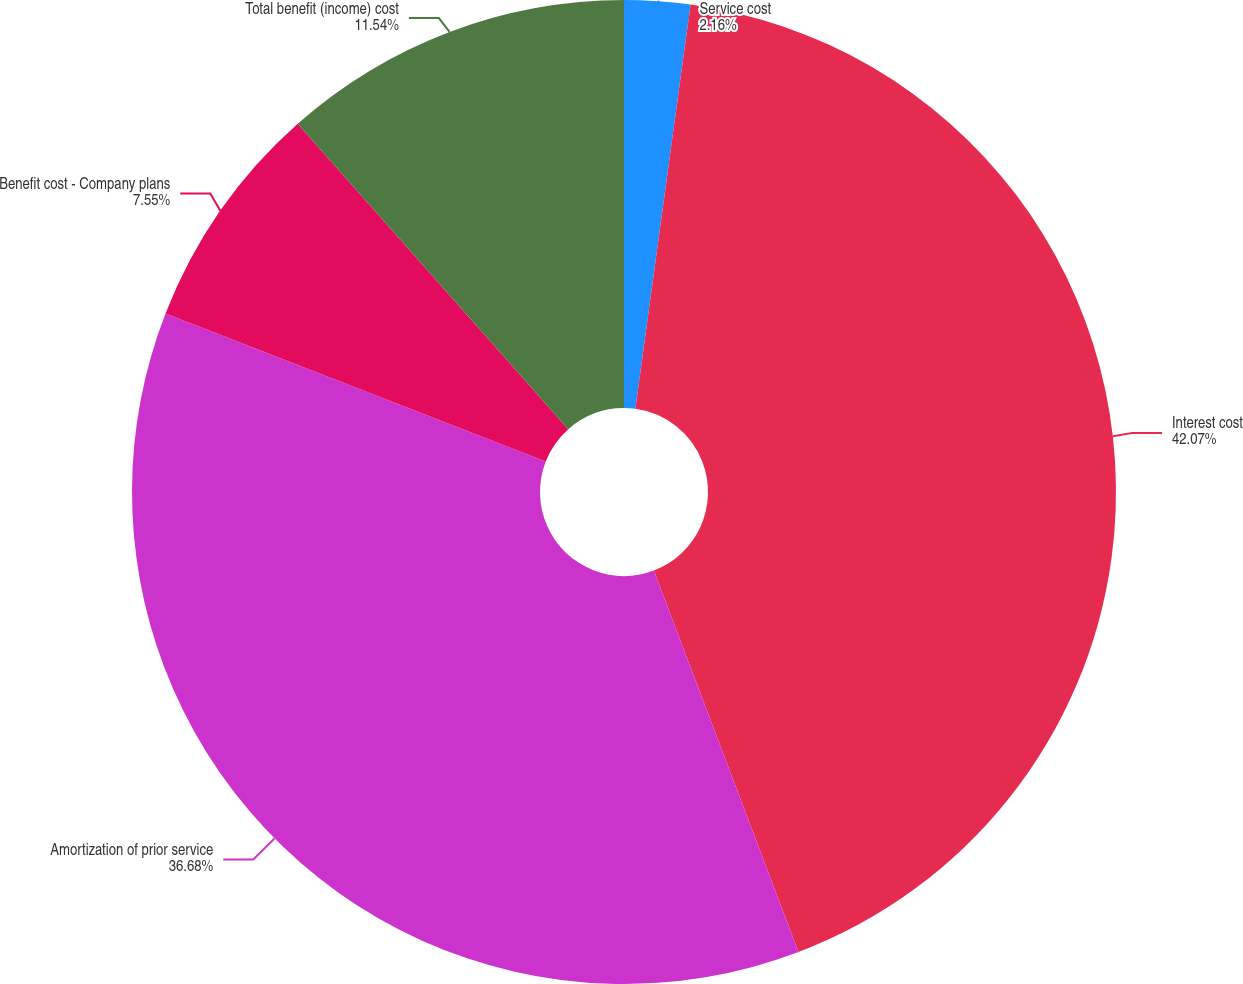Convert chart to OTSL. <chart><loc_0><loc_0><loc_500><loc_500><pie_chart><fcel>Service cost<fcel>Interest cost<fcel>Amortization of prior service<fcel>Benefit cost - Company plans<fcel>Total benefit (income) cost<nl><fcel>2.16%<fcel>42.07%<fcel>36.68%<fcel>7.55%<fcel>11.54%<nl></chart> 